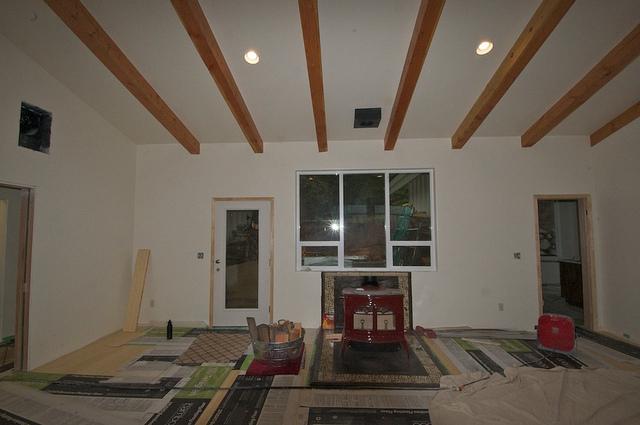Can I start a fire safely?
Answer briefly. No. What color is the garbage can?
Short answer required. Silver. What is leaning against the wall on the back left near the door?
Write a very short answer. Board. Is the lighting recessed?
Be succinct. Yes. What color are the beams?
Write a very short answer. Brown. What architectural feature is this called?
Concise answer only. Beams. 